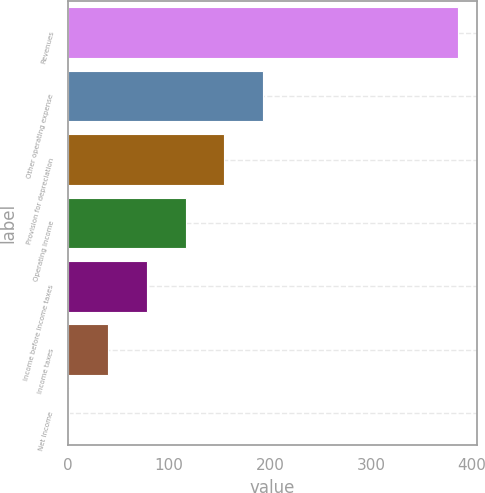Convert chart. <chart><loc_0><loc_0><loc_500><loc_500><bar_chart><fcel>Revenues<fcel>Other operating expense<fcel>Provision for depreciation<fcel>Operating Income<fcel>Income before income taxes<fcel>Income taxes<fcel>Net Income<nl><fcel>386<fcel>193.5<fcel>155<fcel>116.5<fcel>78<fcel>39.5<fcel>1<nl></chart> 